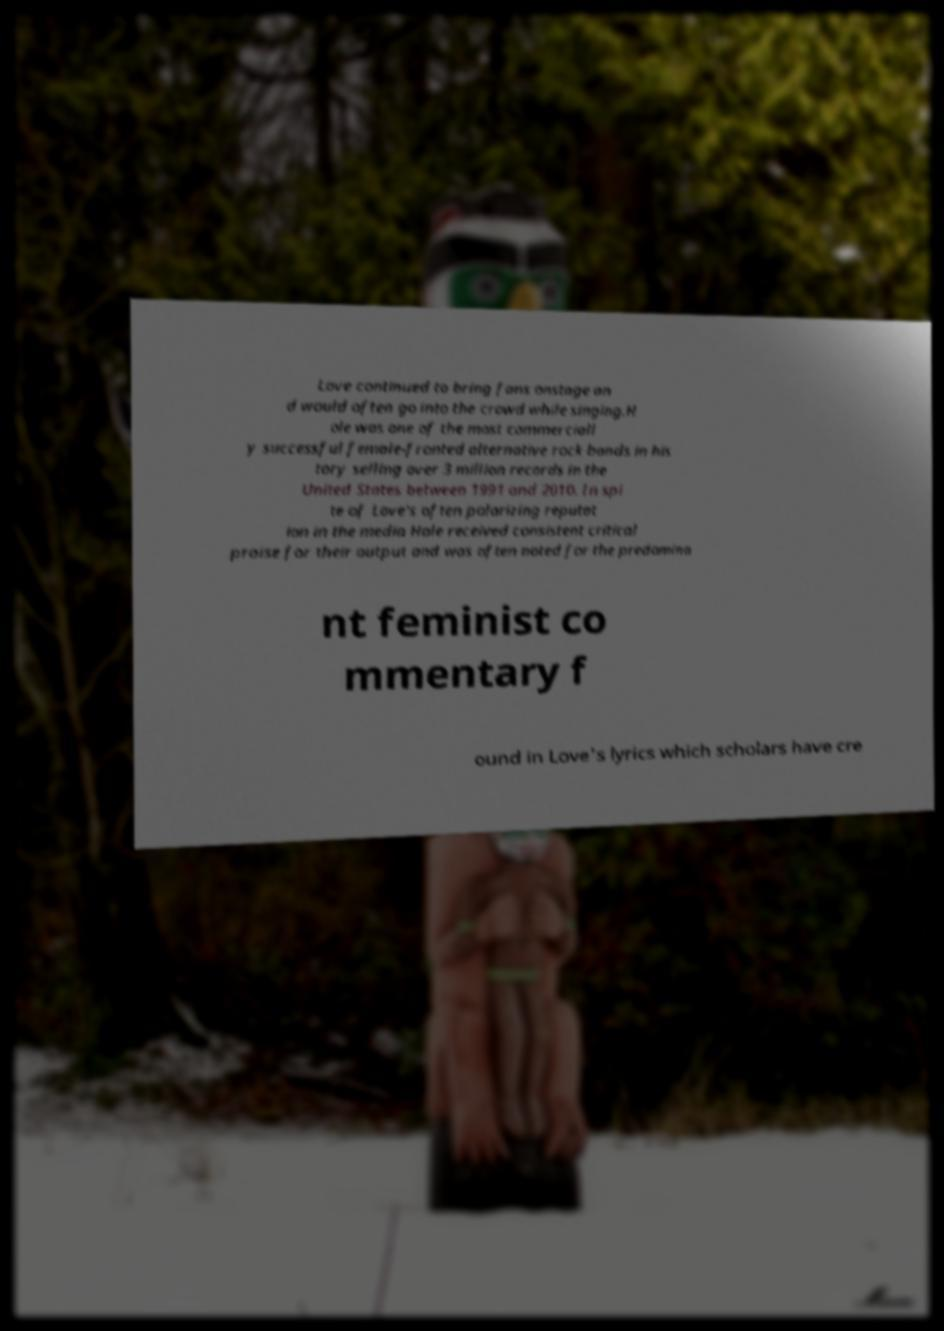For documentation purposes, I need the text within this image transcribed. Could you provide that? Love continued to bring fans onstage an d would often go into the crowd while singing.H ole was one of the most commerciall y successful female-fronted alternative rock bands in his tory selling over 3 million records in the United States between 1991 and 2010. In spi te of Love's often polarizing reputat ion in the media Hole received consistent critical praise for their output and was often noted for the predomina nt feminist co mmentary f ound in Love's lyrics which scholars have cre 